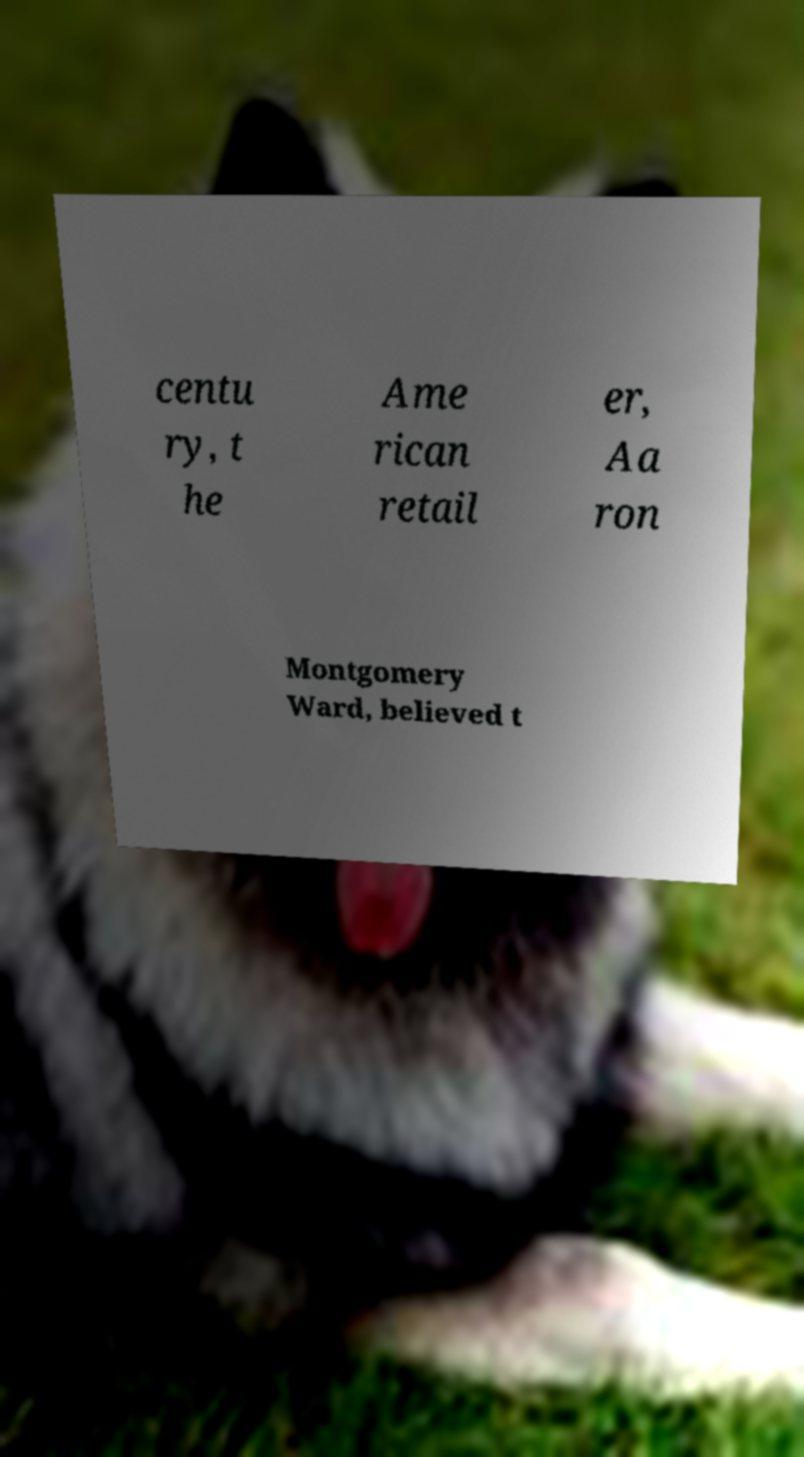What messages or text are displayed in this image? I need them in a readable, typed format. centu ry, t he Ame rican retail er, Aa ron Montgomery Ward, believed t 